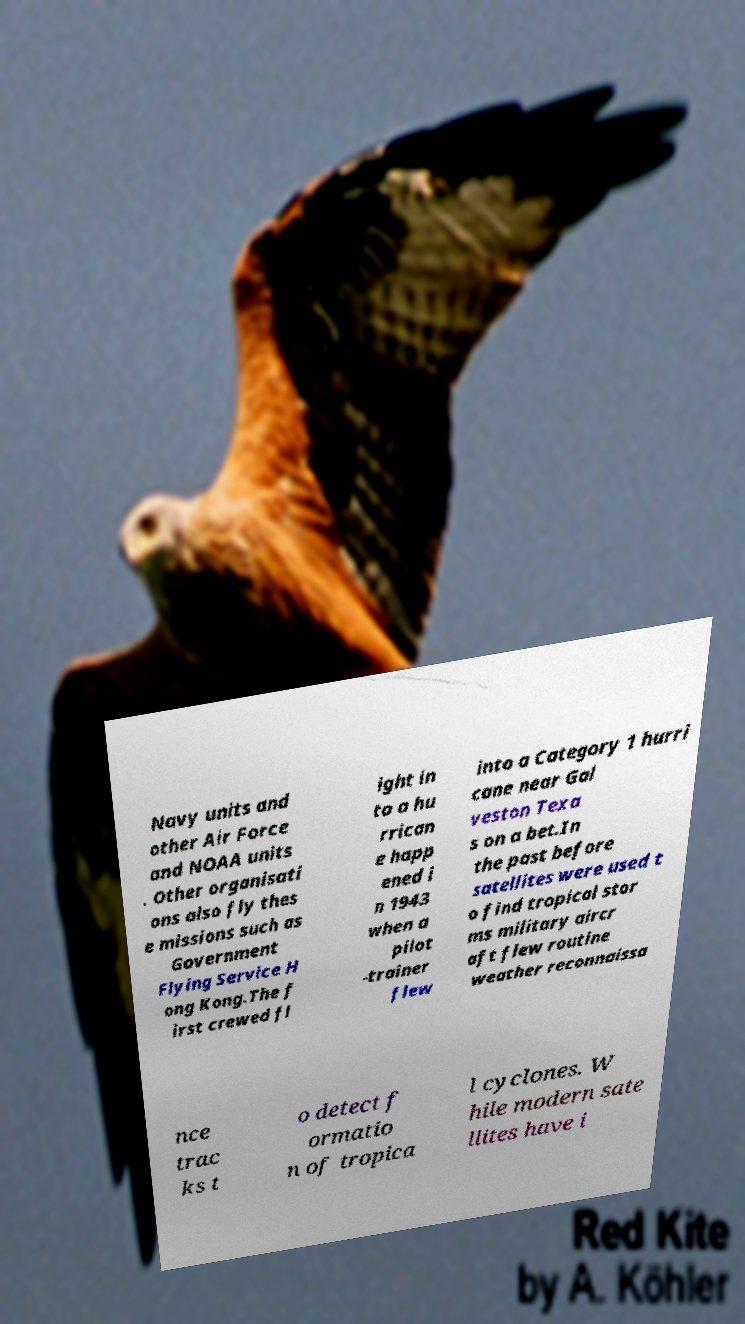Can you read and provide the text displayed in the image?This photo seems to have some interesting text. Can you extract and type it out for me? Navy units and other Air Force and NOAA units . Other organisati ons also fly thes e missions such as Government Flying Service H ong Kong.The f irst crewed fl ight in to a hu rrican e happ ened i n 1943 when a pilot -trainer flew into a Category 1 hurri cane near Gal veston Texa s on a bet.In the past before satellites were used t o find tropical stor ms military aircr aft flew routine weather reconnaissa nce trac ks t o detect f ormatio n of tropica l cyclones. W hile modern sate llites have i 